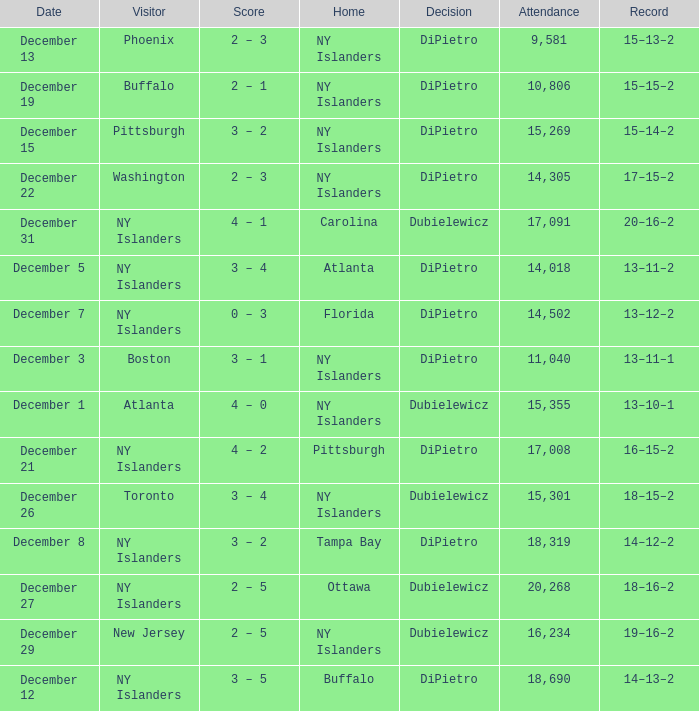Name the date for attendance more than 20,268 None. 